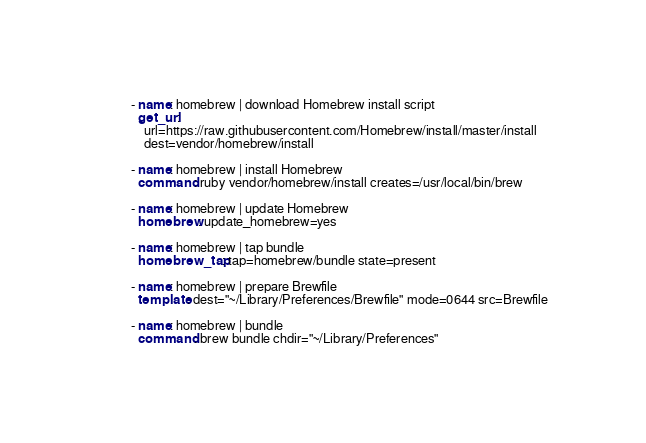<code> <loc_0><loc_0><loc_500><loc_500><_YAML_>- name: homebrew | download Homebrew install script
  get_url:
    url=https://raw.githubusercontent.com/Homebrew/install/master/install
    dest=vendor/homebrew/install

- name: homebrew | install Homebrew
  command: ruby vendor/homebrew/install creates=/usr/local/bin/brew

- name: homebrew | update Homebrew
  homebrew: update_homebrew=yes

- name: homebrew | tap bundle
  homebrew_tap: tap=homebrew/bundle state=present

- name: homebrew | prepare Brewfile
  template: dest="~/Library/Preferences/Brewfile" mode=0644 src=Brewfile

- name: homebrew | bundle
  command: brew bundle chdir="~/Library/Preferences"
</code> 